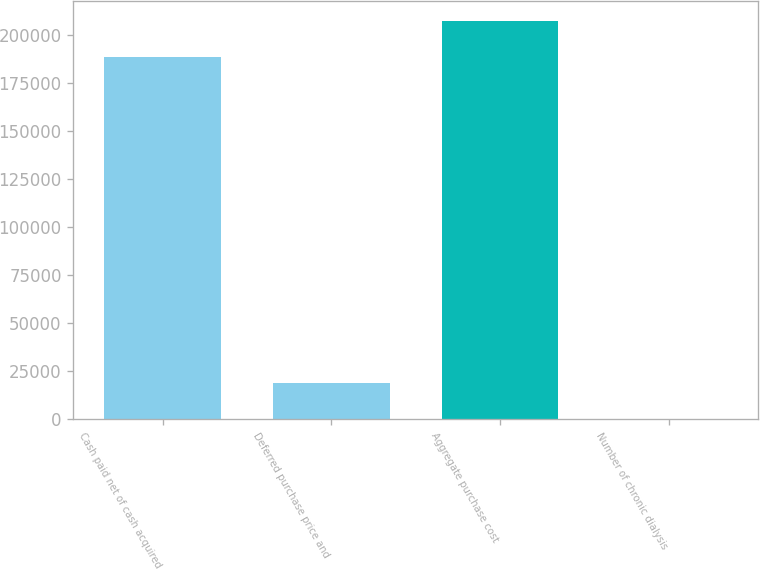Convert chart. <chart><loc_0><loc_0><loc_500><loc_500><bar_chart><fcel>Cash paid net of cash acquired<fcel>Deferred purchase price and<fcel>Aggregate purchase cost<fcel>Number of chronic dialysis<nl><fcel>188502<fcel>18932<fcel>207393<fcel>41<nl></chart> 